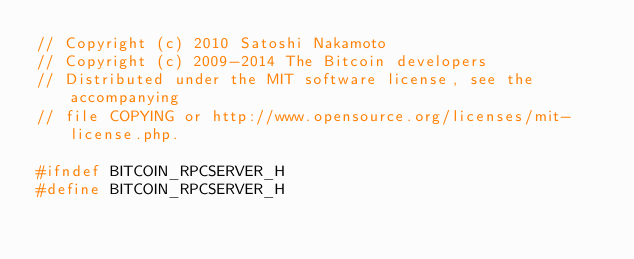<code> <loc_0><loc_0><loc_500><loc_500><_C_>// Copyright (c) 2010 Satoshi Nakamoto
// Copyright (c) 2009-2014 The Bitcoin developers
// Distributed under the MIT software license, see the accompanying
// file COPYING or http://www.opensource.org/licenses/mit-license.php.

#ifndef BITCOIN_RPCSERVER_H
#define BITCOIN_RPCSERVER_H
</code> 